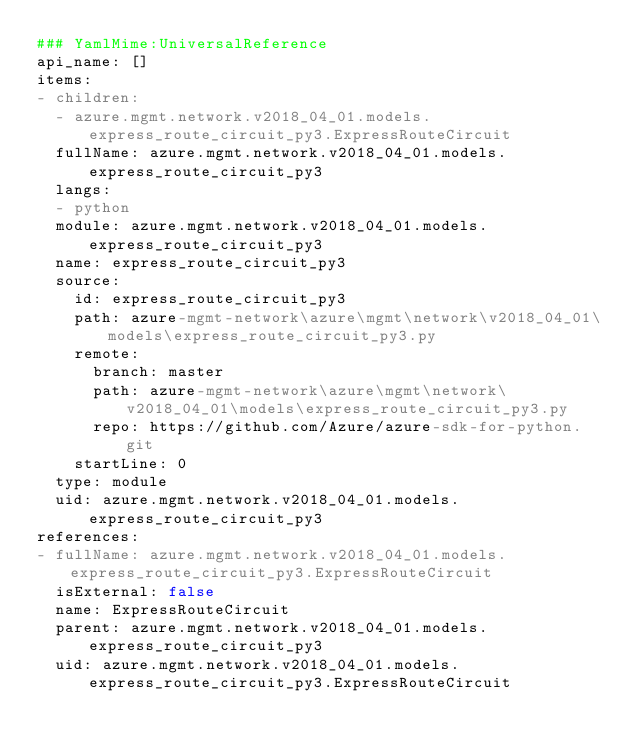<code> <loc_0><loc_0><loc_500><loc_500><_YAML_>### YamlMime:UniversalReference
api_name: []
items:
- children:
  - azure.mgmt.network.v2018_04_01.models.express_route_circuit_py3.ExpressRouteCircuit
  fullName: azure.mgmt.network.v2018_04_01.models.express_route_circuit_py3
  langs:
  - python
  module: azure.mgmt.network.v2018_04_01.models.express_route_circuit_py3
  name: express_route_circuit_py3
  source:
    id: express_route_circuit_py3
    path: azure-mgmt-network\azure\mgmt\network\v2018_04_01\models\express_route_circuit_py3.py
    remote:
      branch: master
      path: azure-mgmt-network\azure\mgmt\network\v2018_04_01\models\express_route_circuit_py3.py
      repo: https://github.com/Azure/azure-sdk-for-python.git
    startLine: 0
  type: module
  uid: azure.mgmt.network.v2018_04_01.models.express_route_circuit_py3
references:
- fullName: azure.mgmt.network.v2018_04_01.models.express_route_circuit_py3.ExpressRouteCircuit
  isExternal: false
  name: ExpressRouteCircuit
  parent: azure.mgmt.network.v2018_04_01.models.express_route_circuit_py3
  uid: azure.mgmt.network.v2018_04_01.models.express_route_circuit_py3.ExpressRouteCircuit
</code> 